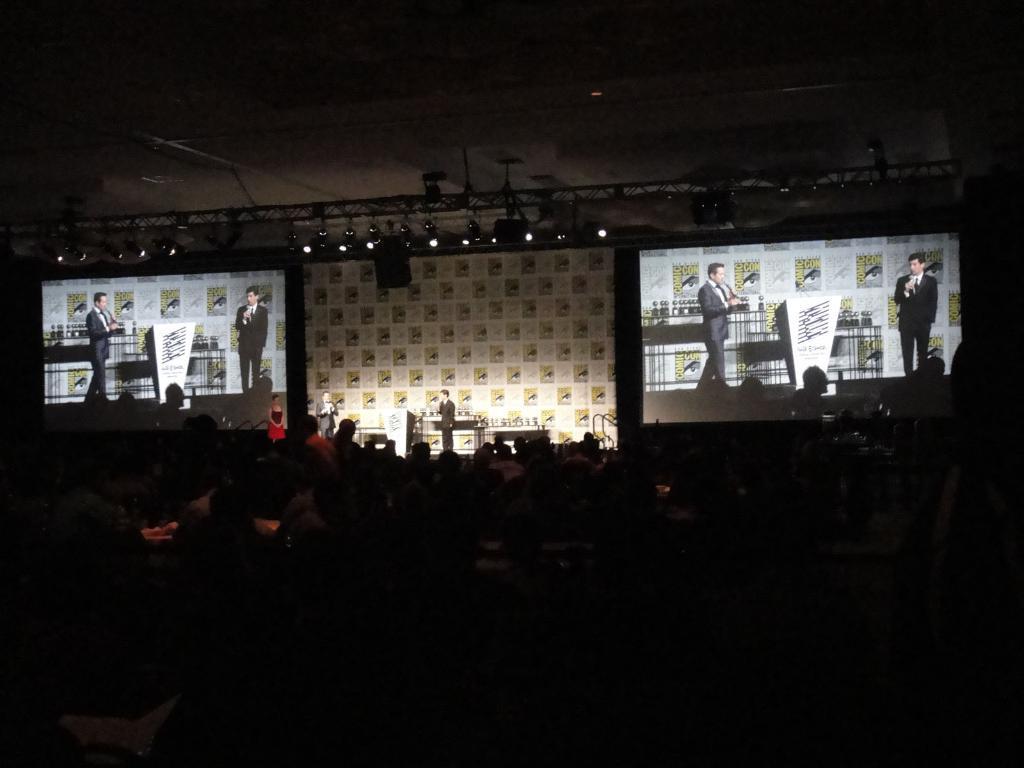How would you summarize this image in a sentence or two? In this image there are a group of persons sitting, there are two men and a woman standing on the stage, there are objects on the stage, there are two screens, there is a wall, there is a speaker, there are lights, there is the roof towards the top of the image, the bottom of the image is dark. 